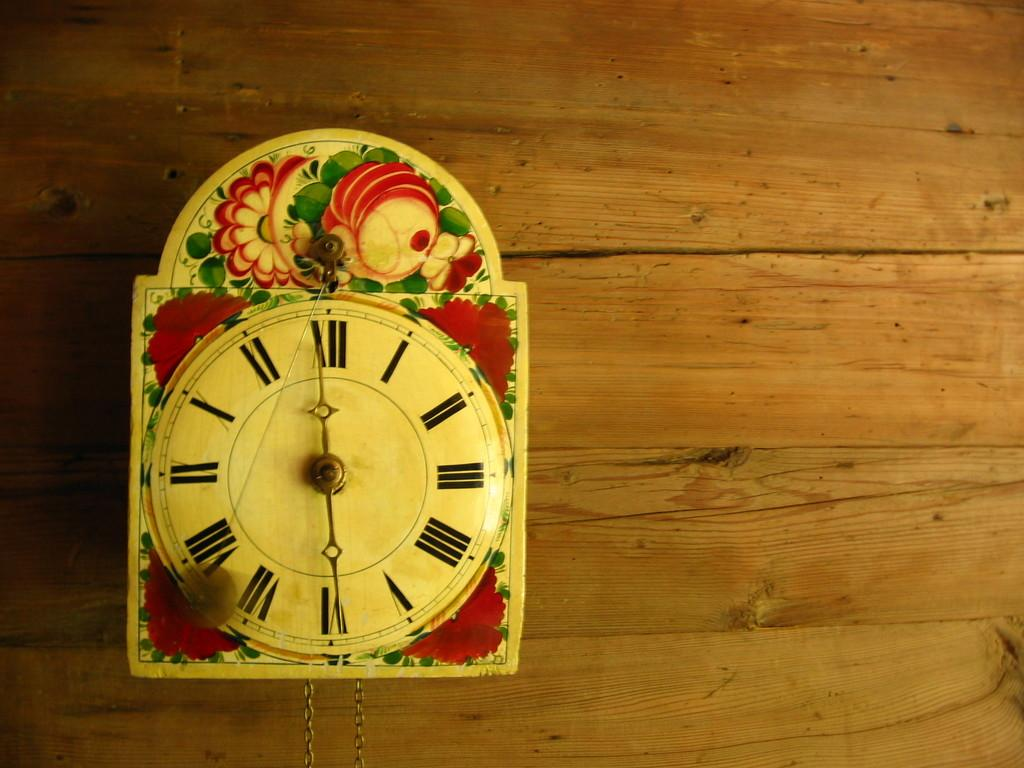What type of object is hanging on the wall in the image? There is a wall clock in the image. What is the wall made of in the image? The wall is made of wood. Can you describe any other objects or features in the image? There is a chain visible in the image. Where is the worm located in the image? There is no worm present in the image. What type of swing can be seen in the image? There is no swing present in the image. 